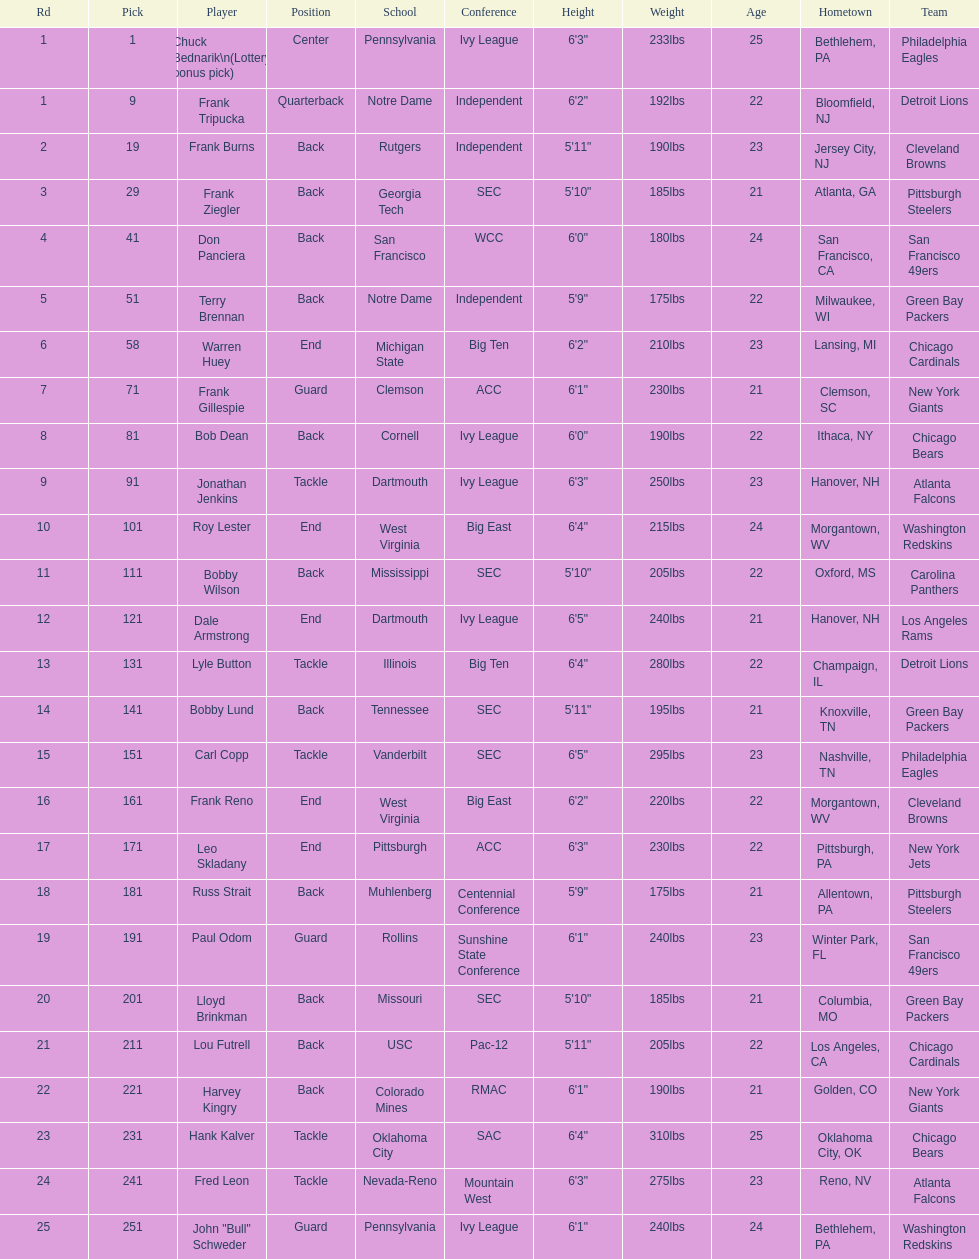Parse the table in full. {'header': ['Rd', 'Pick', 'Player', 'Position', 'School', 'Conference', 'Height', 'Weight', 'Age', 'Hometown', 'Team'], 'rows': [['1', '1', 'Chuck Bednarik\\n(Lottery bonus pick)', 'Center', 'Pennsylvania', 'Ivy League', '6\'3"', '233lbs', '25', 'Bethlehem, PA', 'Philadelphia Eagles'], ['1', '9', 'Frank Tripucka', 'Quarterback', 'Notre Dame', 'Independent', '6\'2"', '192lbs', '22', 'Bloomfield, NJ', 'Detroit Lions'], ['2', '19', 'Frank Burns', 'Back', 'Rutgers', 'Independent', '5\'11"', '190lbs', '23', 'Jersey City, NJ', 'Cleveland  Browns'], ['3', '29', 'Frank Ziegler', 'Back', 'Georgia Tech', 'SEC', '5\'10"', '185lbs', '21', 'Atlanta, GA', 'Pittsburgh Steelers'], ['4', '41', 'Don Panciera', 'Back', 'San Francisco', 'WCC', '6\'0"', '180lbs', '24', 'San Francisco, CA', 'San Francisco 49ers'], ['5', '51', 'Terry Brennan', 'Back', 'Notre Dame', 'Independent', '5\'9"', '175lbs', '22', 'Milwaukee, WI', 'Green Bay Packers'], ['6', '58', 'Warren Huey', 'End', 'Michigan State', 'Big Ten', '6\'2"', '210lbs', '23', 'Lansing, MI', 'Chicago Cardinals'], ['7', '71', 'Frank Gillespie', 'Guard', 'Clemson', 'ACC', '6\'1"', '230lbs', '21', 'Clemson, SC', 'New York Giants'], ['8', '81', 'Bob Dean', 'Back', 'Cornell', 'Ivy League', '6\'0"', '190lbs', '22', 'Ithaca, NY', 'Chicago Bears'], ['9', '91', 'Jonathan Jenkins', 'Tackle', 'Dartmouth', 'Ivy League', '6\'3"', '250lbs', '23', 'Hanover, NH', 'Atlanta Falcons'], ['10', '101', 'Roy Lester', 'End', 'West Virginia', 'Big East', '6\'4"', '215lbs', '24', 'Morgantown, WV', 'Washington Redskins'], ['11', '111', 'Bobby Wilson', 'Back', 'Mississippi', 'SEC', '5\'10"', '205lbs', '22', 'Oxford, MS', 'Carolina Panthers'], ['12', '121', 'Dale Armstrong', 'End', 'Dartmouth', 'Ivy League', '6\'5"', '240lbs', '21', 'Hanover, NH', 'Los Angeles Rams'], ['13', '131', 'Lyle Button', 'Tackle', 'Illinois', 'Big Ten', '6\'4"', '280lbs', '22', 'Champaign, IL', 'Detroit Lions'], ['14', '141', 'Bobby Lund', 'Back', 'Tennessee', 'SEC', '5\'11"', '195lbs', '21', 'Knoxville, TN', 'Green Bay Packers'], ['15', '151', 'Carl Copp', 'Tackle', 'Vanderbilt', 'SEC', '6\'5"', '295lbs', '23', 'Nashville, TN', 'Philadelphia Eagles'], ['16', '161', 'Frank Reno', 'End', 'West Virginia', 'Big East', '6\'2"', '220lbs', '22', 'Morgantown, WV', 'Cleveland Browns'], ['17', '171', 'Leo Skladany', 'End', 'Pittsburgh', 'ACC', '6\'3"', '230lbs', '22', 'Pittsburgh, PA', 'New York Jets'], ['18', '181', 'Russ Strait', 'Back', 'Muhlenberg', 'Centennial Conference', '5\'9"', '175lbs', '21', 'Allentown, PA', 'Pittsburgh Steelers'], ['19', '191', 'Paul Odom', 'Guard', 'Rollins', 'Sunshine State Conference', '6\'1"', '240lbs', '23', 'Winter Park, FL', 'San Francisco 49ers'], ['20', '201', 'Lloyd Brinkman', 'Back', 'Missouri', 'SEC', '5\'10"', '185lbs', '21', 'Columbia, MO', 'Green Bay Packers'], ['21', '211', 'Lou Futrell', 'Back', 'USC', 'Pac-12', '5\'11"', '205lbs', '22', 'Los Angeles, CA', 'Chicago Cardinals'], ['22', '221', 'Harvey Kingry', 'Back', 'Colorado Mines', 'RMAC', '6\'1"', '190lbs', '21', 'Golden, CO', 'New York Giants'], ['23', '231', 'Hank Kalver', 'Tackle', 'Oklahoma City', 'SAC', '6\'4"', '310lbs', '25', 'Oklahoma City, OK', 'Chicago Bears'], ['24', '241', 'Fred Leon', 'Tackle', 'Nevada-Reno', 'Mountain West', '6\'3"', '275lbs', '23', 'Reno, NV', 'Atlanta Falcons'], ['25', '251', 'John "Bull" Schweder', 'Guard', 'Pennsylvania', 'Ivy League', '6\'1"', '240lbs', '24', 'Bethlehem, PA', 'Washington Redskins']]} Who was picked after roy lester? Bobby Wilson. 